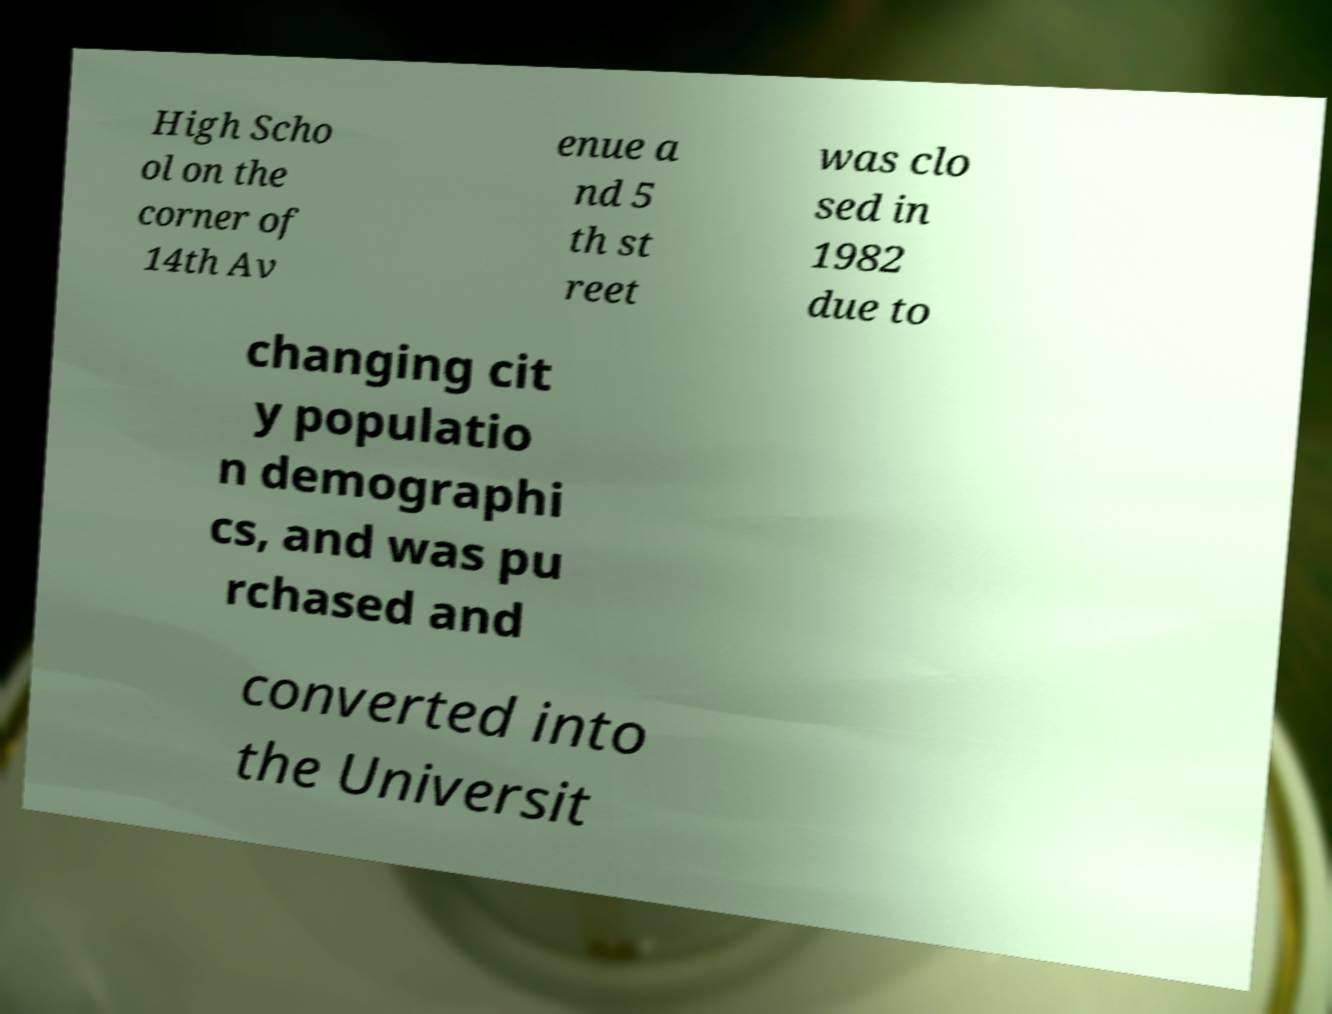Can you accurately transcribe the text from the provided image for me? High Scho ol on the corner of 14th Av enue a nd 5 th st reet was clo sed in 1982 due to changing cit y populatio n demographi cs, and was pu rchased and converted into the Universit 